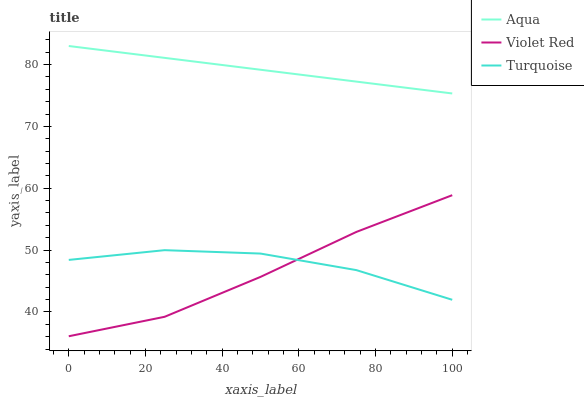Does Violet Red have the minimum area under the curve?
Answer yes or no. Yes. Does Aqua have the maximum area under the curve?
Answer yes or no. Yes. Does Turquoise have the minimum area under the curve?
Answer yes or no. No. Does Turquoise have the maximum area under the curve?
Answer yes or no. No. Is Aqua the smoothest?
Answer yes or no. Yes. Is Turquoise the roughest?
Answer yes or no. Yes. Is Turquoise the smoothest?
Answer yes or no. No. Is Aqua the roughest?
Answer yes or no. No. Does Violet Red have the lowest value?
Answer yes or no. Yes. Does Turquoise have the lowest value?
Answer yes or no. No. Does Aqua have the highest value?
Answer yes or no. Yes. Does Turquoise have the highest value?
Answer yes or no. No. Is Turquoise less than Aqua?
Answer yes or no. Yes. Is Aqua greater than Turquoise?
Answer yes or no. Yes. Does Violet Red intersect Turquoise?
Answer yes or no. Yes. Is Violet Red less than Turquoise?
Answer yes or no. No. Is Violet Red greater than Turquoise?
Answer yes or no. No. Does Turquoise intersect Aqua?
Answer yes or no. No. 